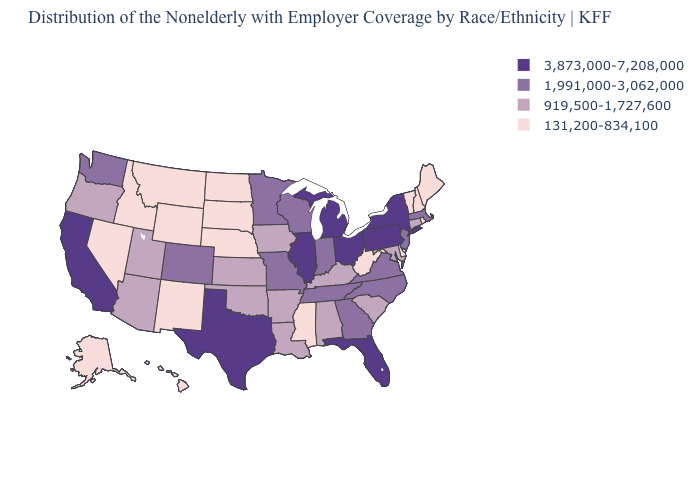Does Oregon have the highest value in the USA?
Answer briefly. No. Does Connecticut have a higher value than Maine?
Concise answer only. Yes. What is the value of Idaho?
Keep it brief. 131,200-834,100. What is the value of Nebraska?
Be succinct. 131,200-834,100. Is the legend a continuous bar?
Concise answer only. No. What is the lowest value in the USA?
Be succinct. 131,200-834,100. What is the value of Montana?
Answer briefly. 131,200-834,100. Name the states that have a value in the range 131,200-834,100?
Give a very brief answer. Alaska, Delaware, Hawaii, Idaho, Maine, Mississippi, Montana, Nebraska, Nevada, New Hampshire, New Mexico, North Dakota, Rhode Island, South Dakota, Vermont, West Virginia, Wyoming. What is the highest value in states that border Rhode Island?
Write a very short answer. 1,991,000-3,062,000. Does Arizona have the lowest value in the West?
Be succinct. No. What is the value of New York?
Quick response, please. 3,873,000-7,208,000. What is the value of New Jersey?
Concise answer only. 1,991,000-3,062,000. What is the value of Michigan?
Concise answer only. 3,873,000-7,208,000. What is the value of Colorado?
Quick response, please. 1,991,000-3,062,000. Name the states that have a value in the range 131,200-834,100?
Concise answer only. Alaska, Delaware, Hawaii, Idaho, Maine, Mississippi, Montana, Nebraska, Nevada, New Hampshire, New Mexico, North Dakota, Rhode Island, South Dakota, Vermont, West Virginia, Wyoming. 